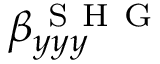<formula> <loc_0><loc_0><loc_500><loc_500>\beta _ { y y y } ^ { S H G }</formula> 